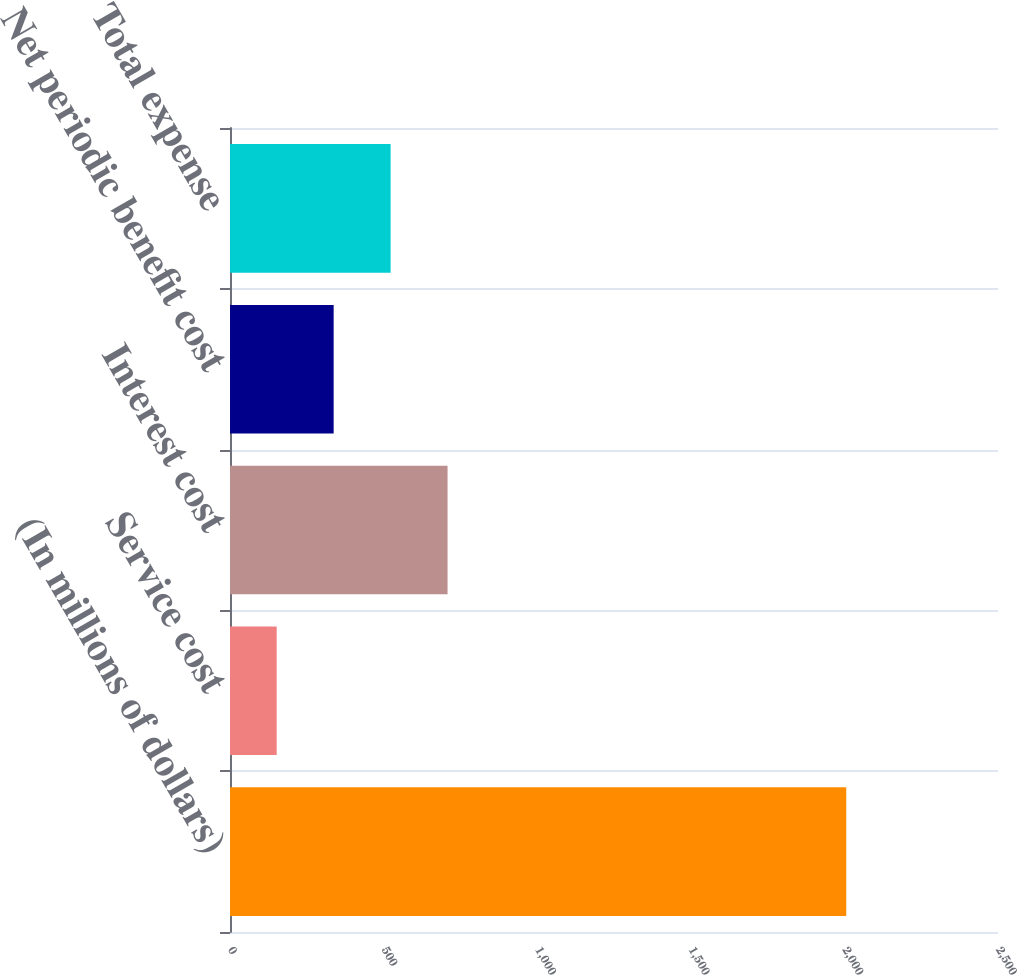<chart> <loc_0><loc_0><loc_500><loc_500><bar_chart><fcel>(In millions of dollars)<fcel>Service cost<fcel>Interest cost<fcel>Net periodic benefit cost<fcel>Total expense<nl><fcel>2006<fcel>152<fcel>708.2<fcel>337.4<fcel>522.8<nl></chart> 